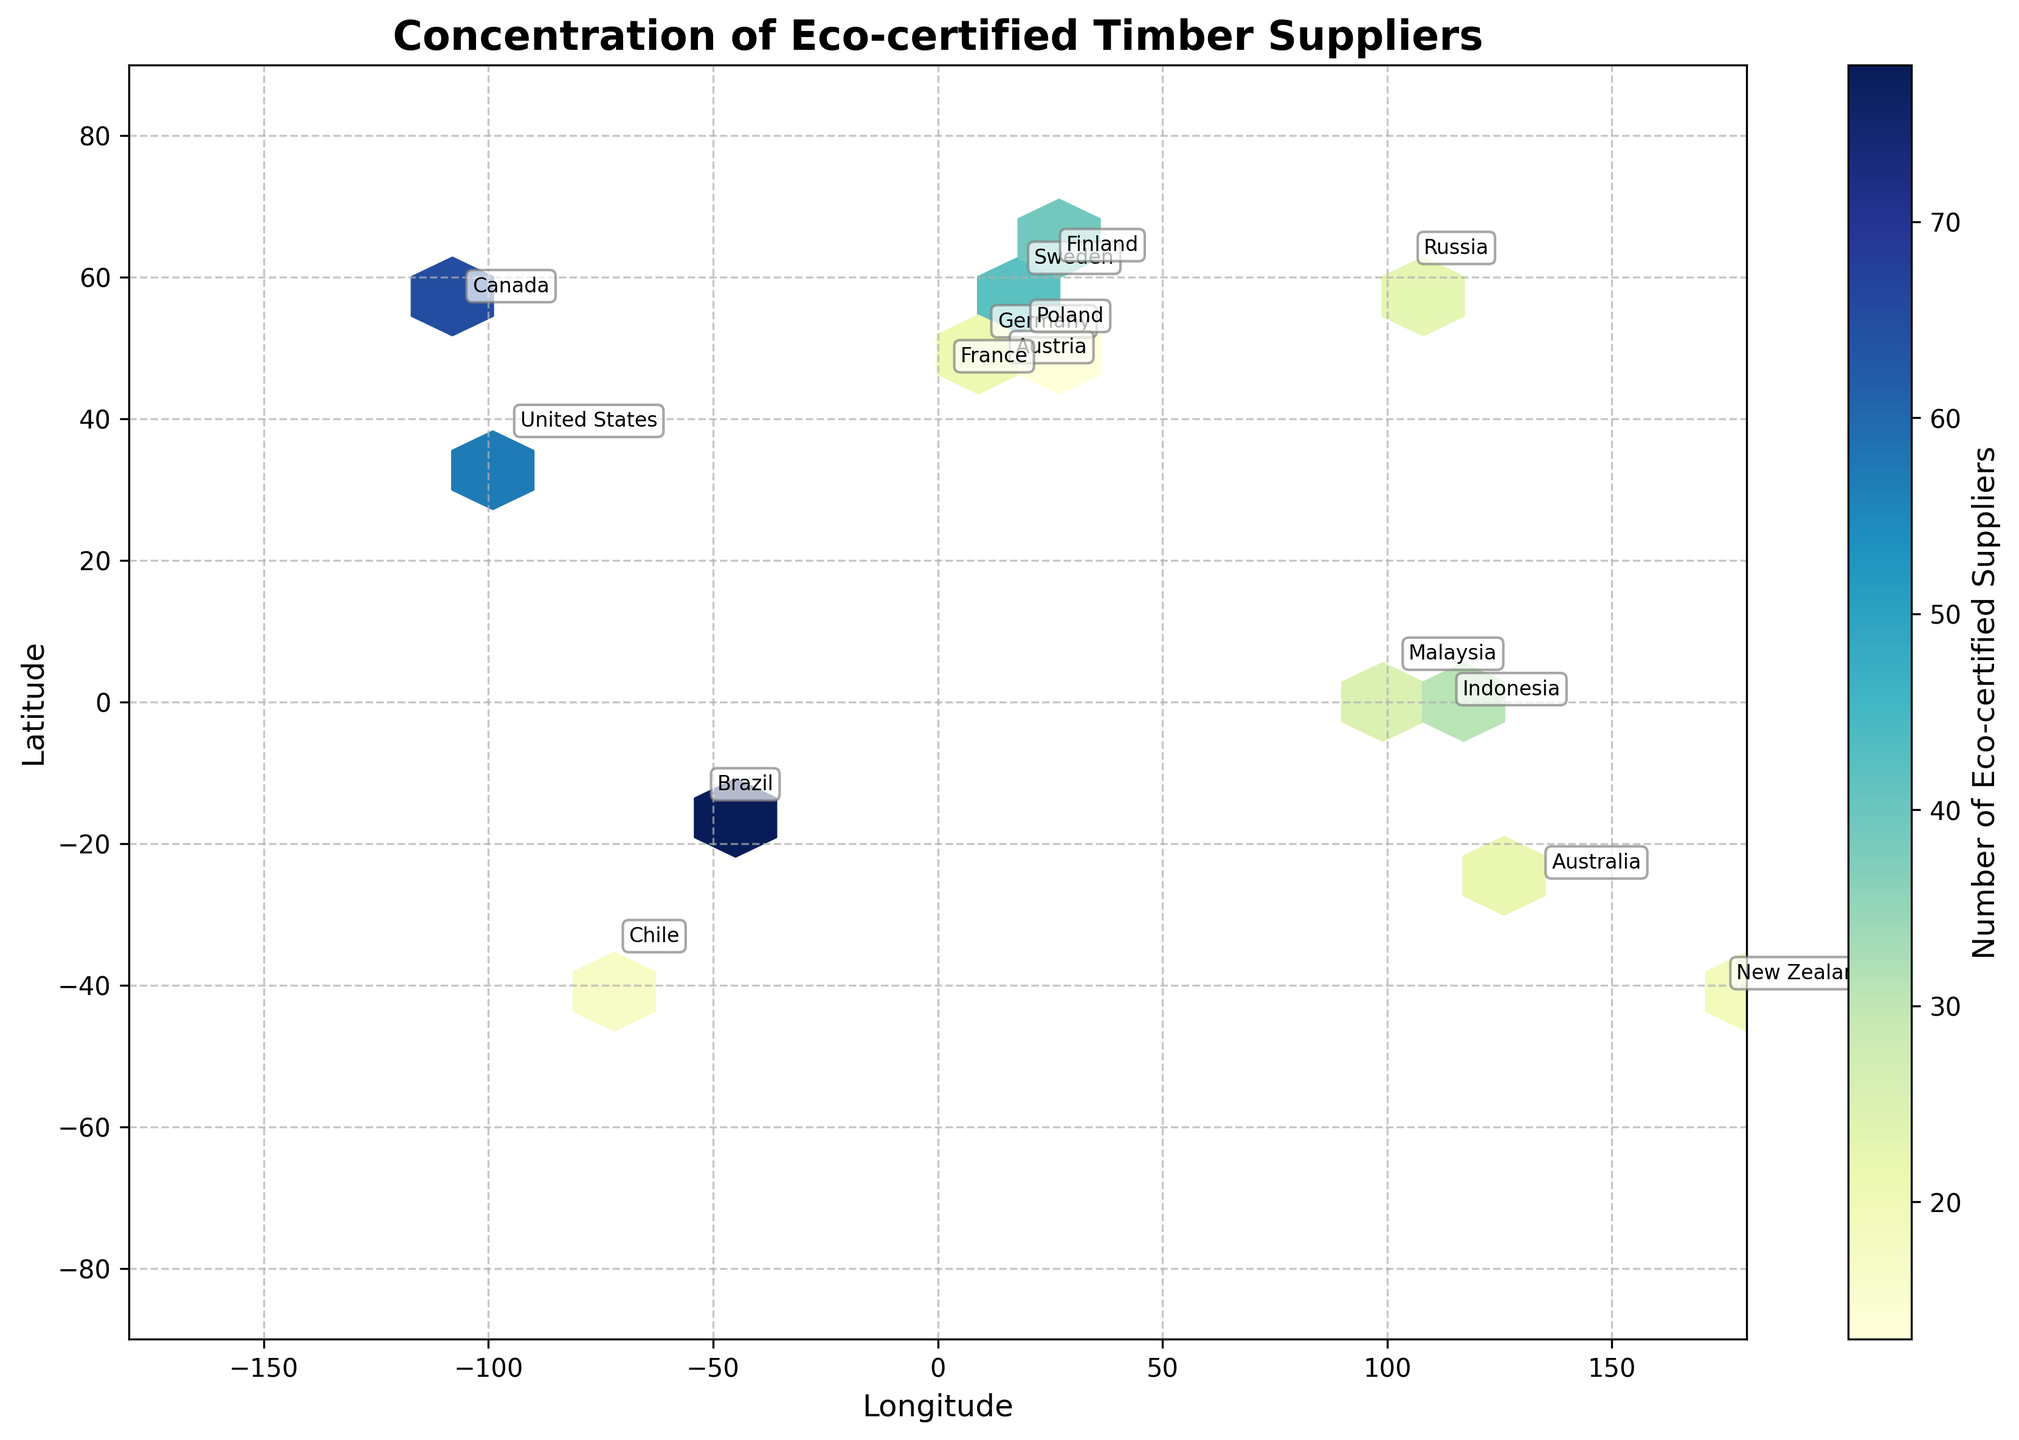What is the title of the hexbin plot? The title is generally at the top of the plot and is typically the biggest text element. In this plot, it reads "Concentration of Eco-certified Timber Suppliers."
Answer: Concentration of Eco-certified Timber Suppliers What does the color bar on the right represent? The color bar next to the plot usually indicates what the colors in the hexbin represent. In this case, it is labeled "Number of Eco-certified Suppliers."
Answer: Number of Eco-certified Suppliers Which country has the highest number of eco-certified timber suppliers? The country label closest to the darkest hexbin cell will have the highest number of eco-certified suppliers. Here, Brazil is positioned near the darkest areas.
Answer: Brazil How many eco-certified timber suppliers are there in Canada? Since each country’s eco-certified timber suppliers count is annotated near its position, you can find Canada and check its label. It shows 65 suppliers.
Answer: 65 Which two countries near the equator have notable concentrations of eco-certified timber suppliers? By looking at the hexbin plot areas close to the equator (latitude 0°), Brazil and Indonesia appear to have notable concentrations. Brazil has 78, while Indonesia has 31 eco-certified timber suppliers.
Answer: Brazil and Indonesia What is the latitude range covered by the plot? The latitude range can be identified by checking the y-axis limits. In this plot, the y-axis covers from -90 to 90.
Answer: -90 to 90 Compare the number of suppliers in Sweden and Austria. Which has more? Referring to the annotated counts, Sweden has 42 suppliers while Austria has 21. Therefore, Sweden has more suppliers than Austria.
Answer: Sweden Which region appears to have a dense concentration of suppliers based on longitude? The hexbin shades along the longitude axis provide insights into dense regions. The darkest hexbin area in the longitude range -50 to -120 (Western Hemisphere) indicates a dense concentration.
Answer: Western Hemisphere If you sum the suppliers from the United States, Germany, and France, what is the total? Adding the eco-certified suppliers count from each labeled country: United States (57), Germany (28), and France (15) gives a total of 57 + 28 + 15 = 100.
Answer: 100 What is the color scheme used in the hexbin plot and what does it signify? The plot uses a color gradient running from lighter shades to darker ones within the 'YlGnBu' (Yellow-Green-Blue) colormap, which signifies an increasing number of eco-certified timber suppliers.
Answer: YlGnBu colormap, higher values are darker 